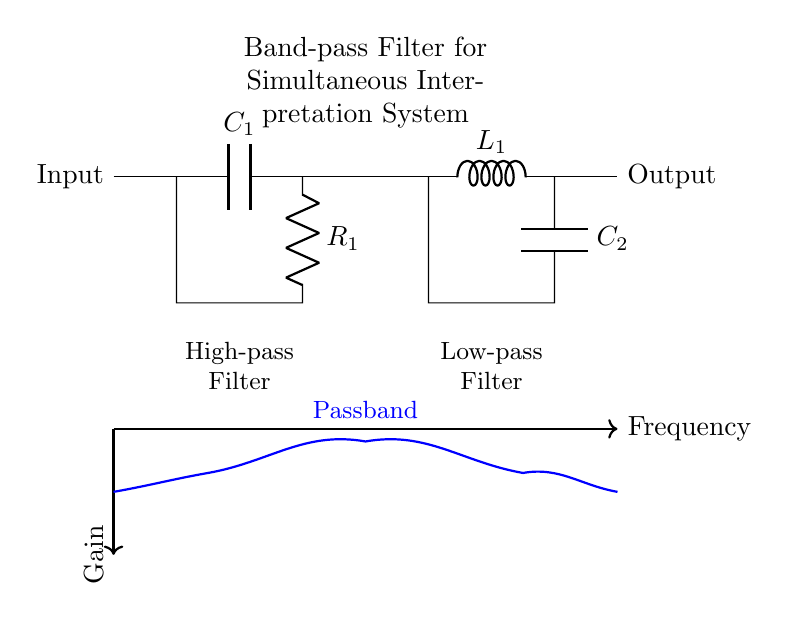What type of filter is depicted in the diagram? The circuit shows a band-pass filter, which is indicated in the label in the center of the diagram. A band-pass filter allows a specific range of frequencies to pass while attenuating frequencies outside this range.
Answer: band-pass filter What components are used in the high-pass filter section? The high-pass filter section comprises a capacitor named C1 and a resistor named R1. The positions of these components can be observed in the left part of the circuit diagram.
Answer: C1 and R1 What is the role of the inductor in the circuit? The inductor, labeled as L1, is part of the low-pass filter section. It allows low-frequency signals to pass while blocking higher frequencies, thus contributing to the overall band-pass behavior of the filter.
Answer: Low-pass filter How many passive components are used in the circuit? There are a total of four passive components in the circuit: two capacitors (C1 and C2), one inductor (L1), and one resistor (R1). This is determined by counting each component shown in the circuit diagram.
Answer: Four What does the blue curve in the diagram represent? The blue curve illustrates the frequency response of the band-pass filter, showcasing the gain across different frequencies, with the passband marked between the rising and falling sections of the curve.
Answer: Gain versus frequency What is the function of the capacitor C2? Capacitor C2 is part of the low-pass filter section, filtering high frequencies and contributing to the overall band-pass characteristic by allowing specific lower frequencies to pass.
Answer: Low-pass filter function What type of filtering does the combination of the components achieve? The combination of a high-pass filter section (C1 and R1) and a low-pass filter section (L1 and C2) creates a filter that only allows a certain range of frequencies to pass, which is characteristic of band-pass filtering.
Answer: Band-pass filtering 